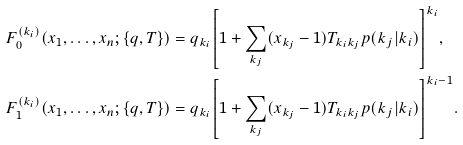Convert formula to latex. <formula><loc_0><loc_0><loc_500><loc_500>F _ { 0 } ^ { ( k _ { i } ) } ( x _ { 1 } , \dots , x _ { n } ; \{ q , T \} ) & = q _ { k _ { i } } { \left [ 1 + \sum _ { k _ { j } } ( x _ { k _ { j } } - 1 ) T _ { k _ { i } k _ { j } } p ( k _ { j } | k _ { i } ) \right ] } ^ { k _ { i } } , \\ F _ { 1 } ^ { ( k _ { i } ) } ( x _ { 1 } , \dots , x _ { n } ; \{ q , T \} ) & = q _ { k _ { i } } { \left [ 1 + \sum _ { k _ { j } } ( x _ { k _ { j } } - 1 ) T _ { k _ { i } k _ { j } } p ( k _ { j } | k _ { i } ) \right ] } ^ { k _ { i } - 1 } .</formula> 